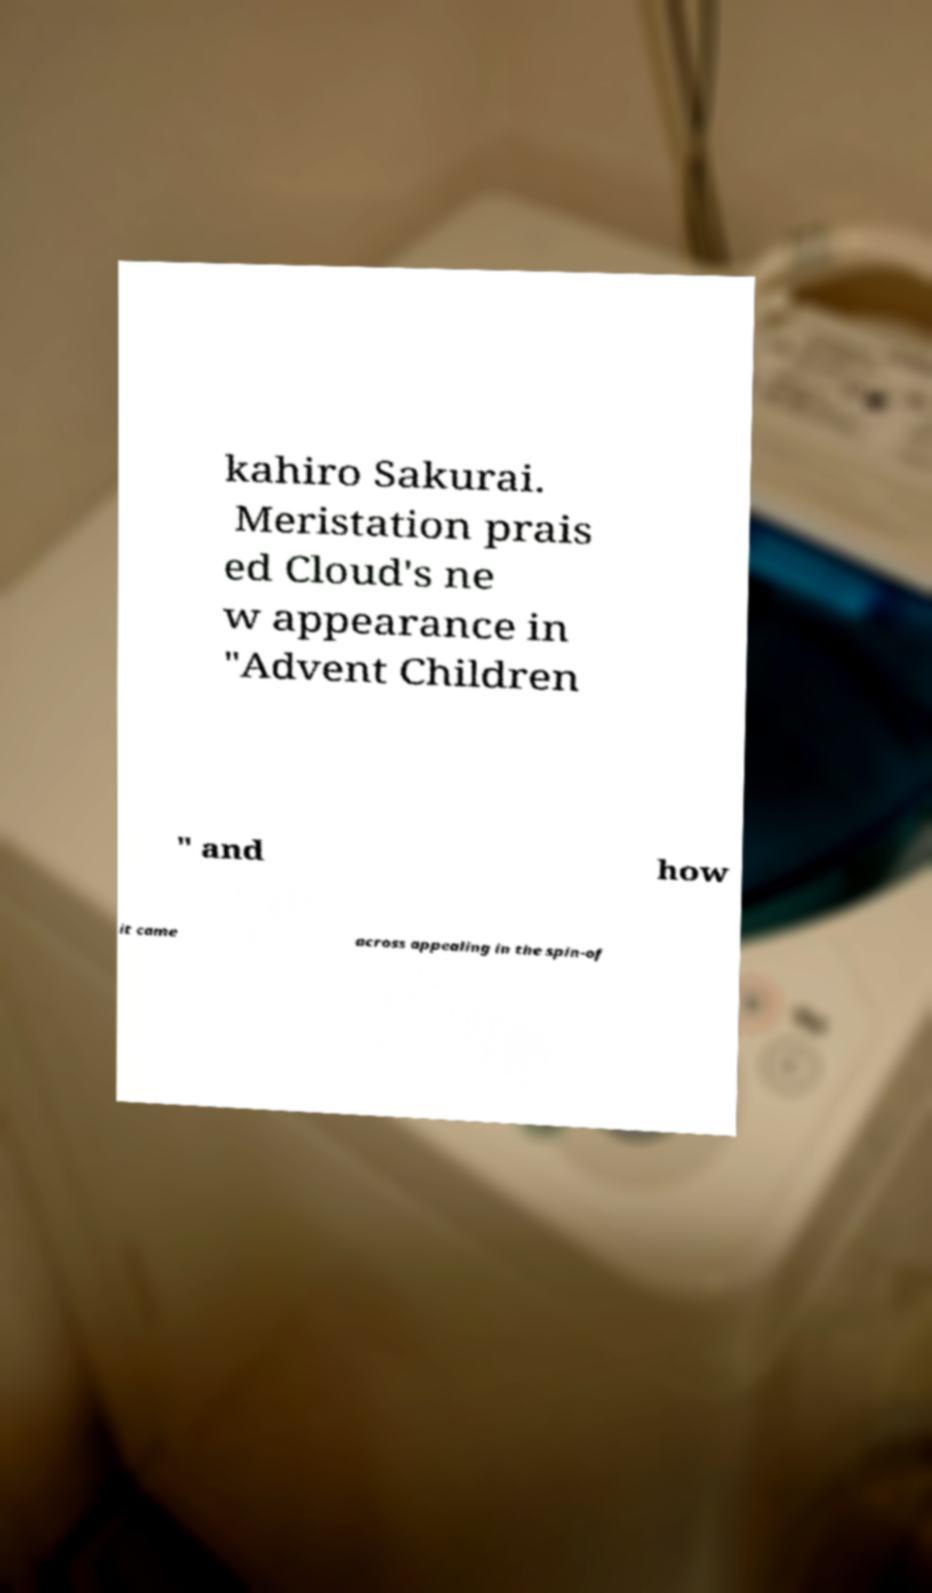Can you read and provide the text displayed in the image?This photo seems to have some interesting text. Can you extract and type it out for me? kahiro Sakurai. Meristation prais ed Cloud's ne w appearance in "Advent Children " and how it came across appealing in the spin-of 